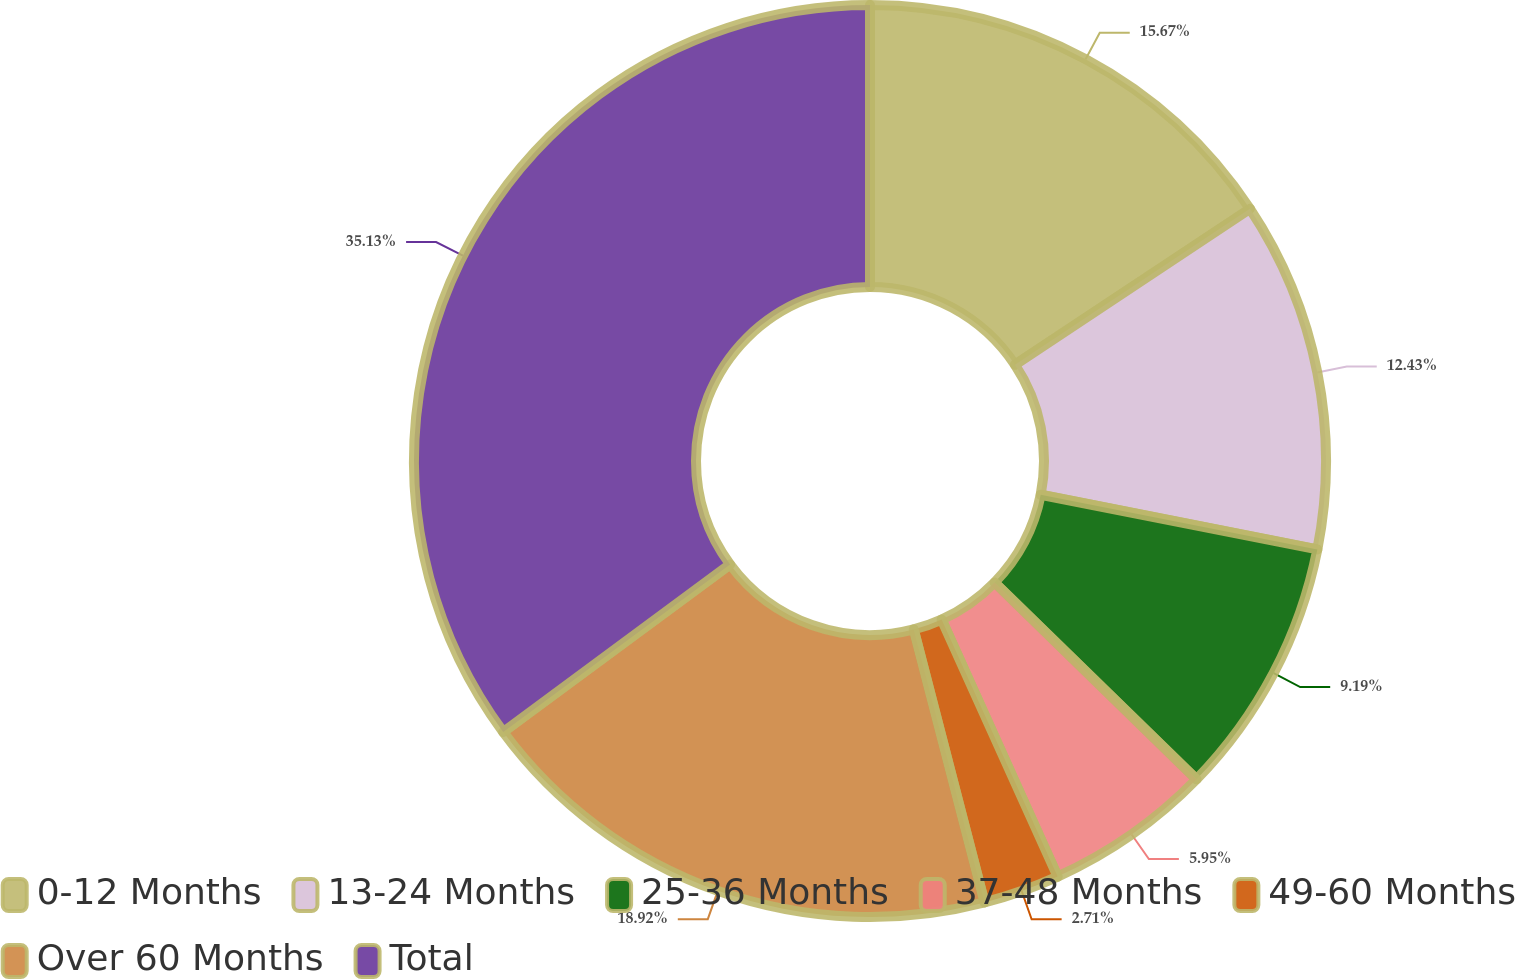<chart> <loc_0><loc_0><loc_500><loc_500><pie_chart><fcel>0-12 Months<fcel>13-24 Months<fcel>25-36 Months<fcel>37-48 Months<fcel>49-60 Months<fcel>Over 60 Months<fcel>Total<nl><fcel>15.67%<fcel>12.43%<fcel>9.19%<fcel>5.95%<fcel>2.71%<fcel>18.91%<fcel>35.12%<nl></chart> 